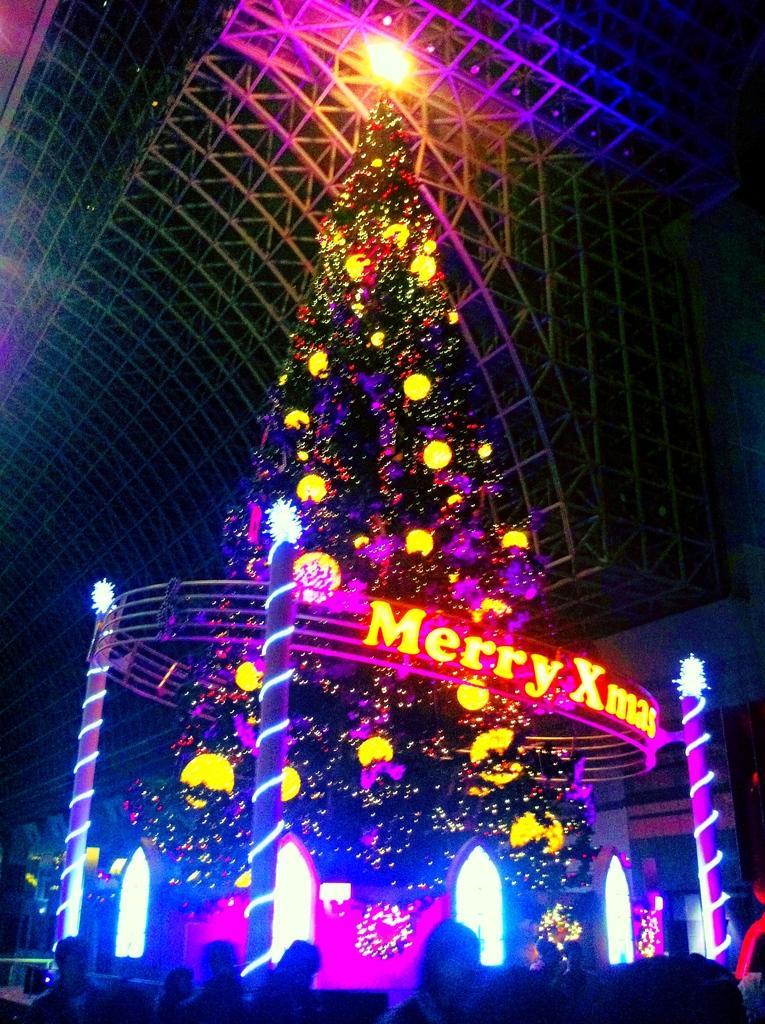How would you summarize this image in a sentence or two? As we can see in the image there are few people, lights, decorative items and a Christmas tree. The image is little dark. 